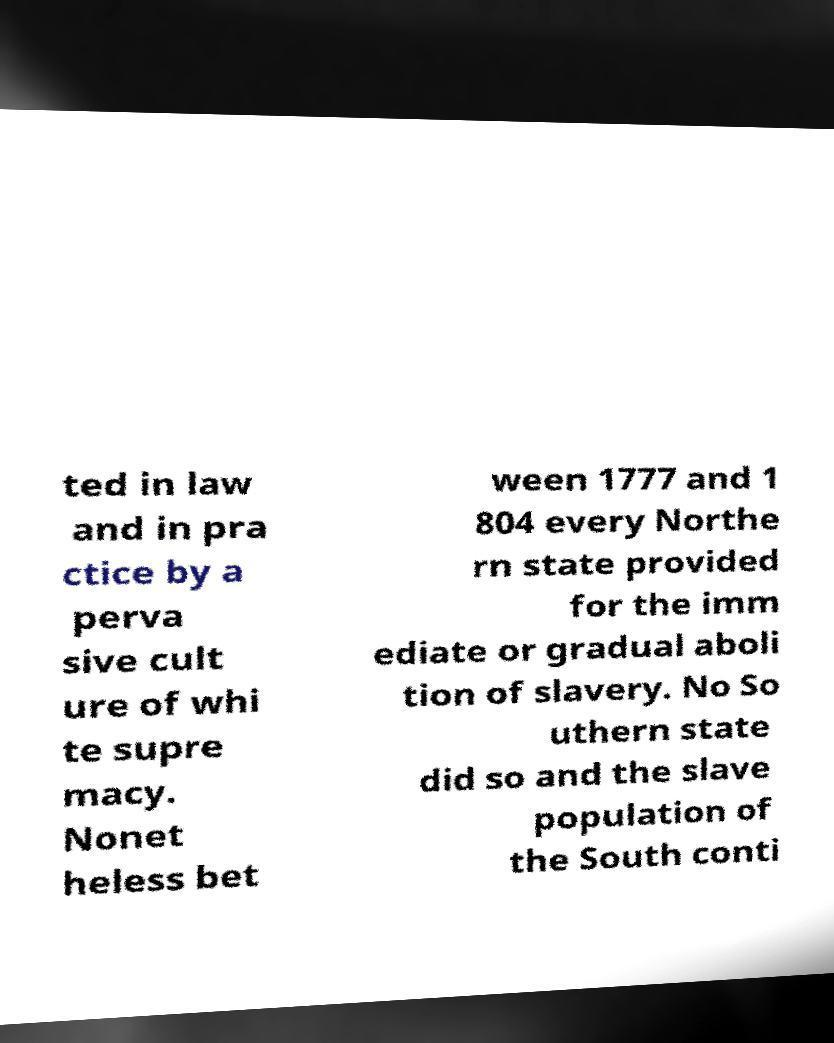There's text embedded in this image that I need extracted. Can you transcribe it verbatim? ted in law and in pra ctice by a perva sive cult ure of whi te supre macy. Nonet heless bet ween 1777 and 1 804 every Northe rn state provided for the imm ediate or gradual aboli tion of slavery. No So uthern state did so and the slave population of the South conti 